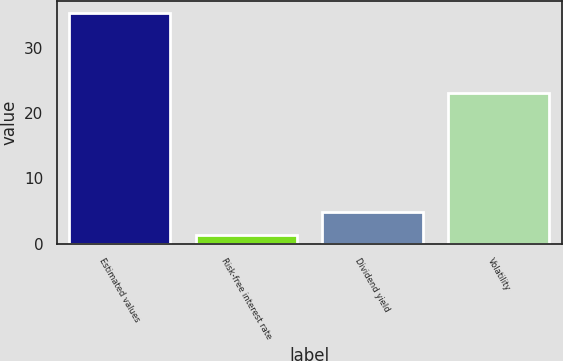<chart> <loc_0><loc_0><loc_500><loc_500><bar_chart><fcel>Estimated values<fcel>Risk-free interest rate<fcel>Dividend yield<fcel>Volatility<nl><fcel>35.3<fcel>1.4<fcel>4.79<fcel>23<nl></chart> 